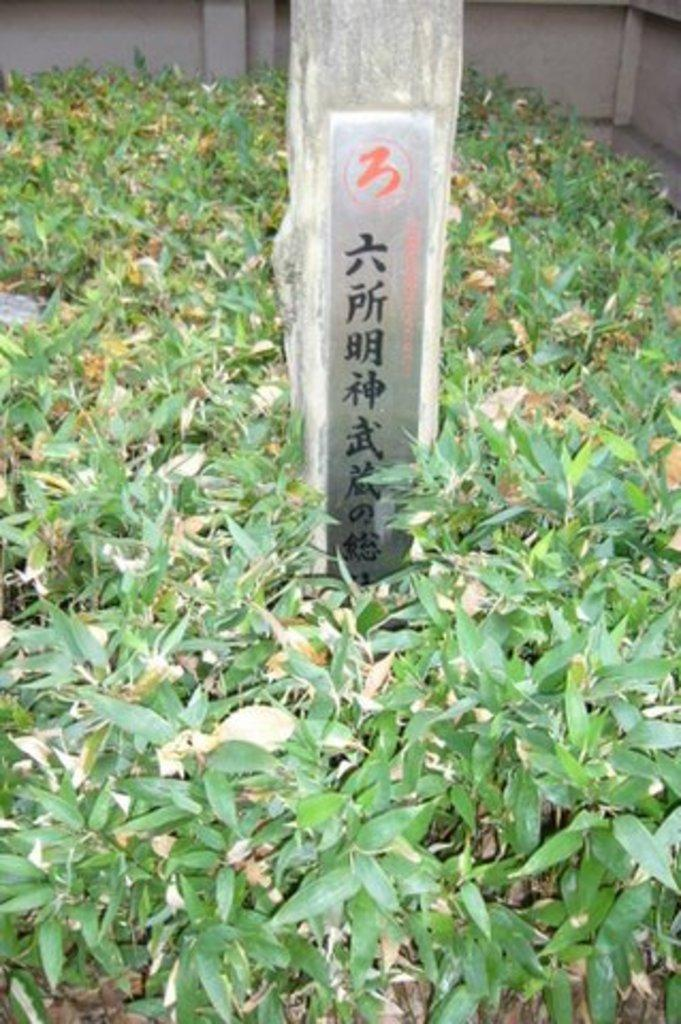What is the main object in the center of the image? There is an object with text in the center of the image. What type of vegetation can be seen in the image? There are green leaves visible in the image. Are there any other objects present in the image besides the one with text? Yes, there are other objects present in the image. How many times does the word "low" appear in the text of the object in the image? The word "low" does not appear in the text of the object in the image, as there is no reference to it in the provided facts. 